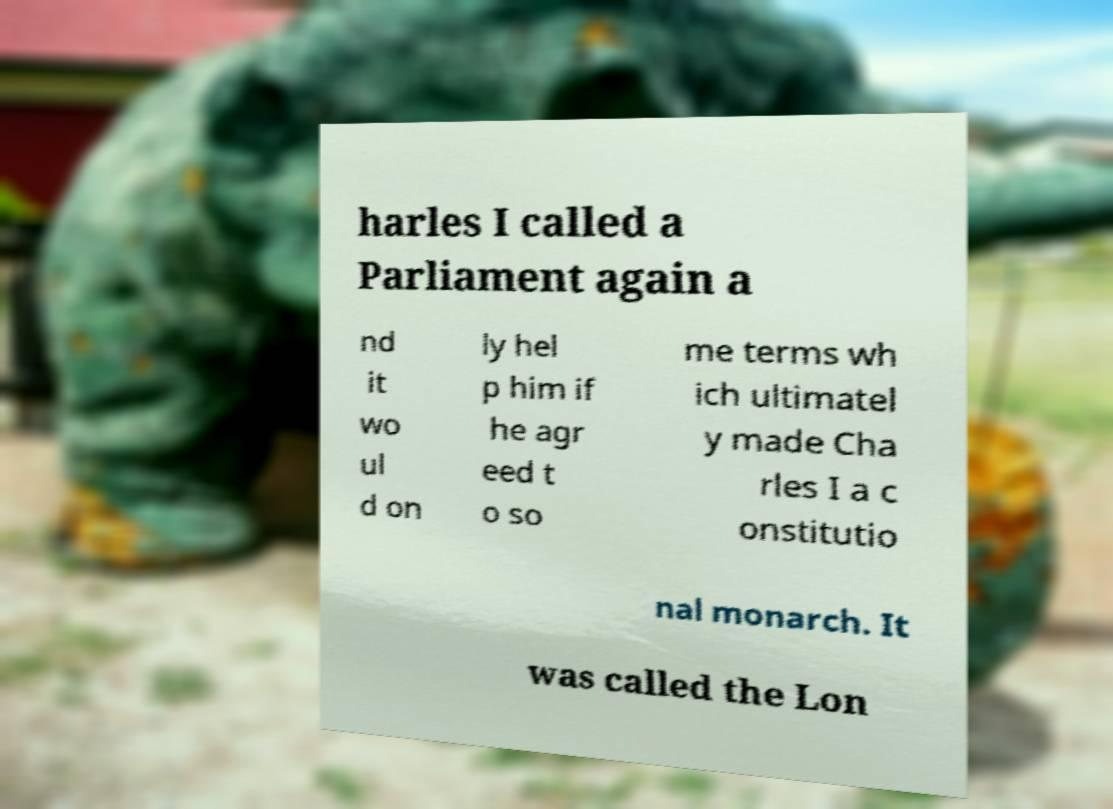Can you accurately transcribe the text from the provided image for me? harles I called a Parliament again a nd it wo ul d on ly hel p him if he agr eed t o so me terms wh ich ultimatel y made Cha rles I a c onstitutio nal monarch. It was called the Lon 